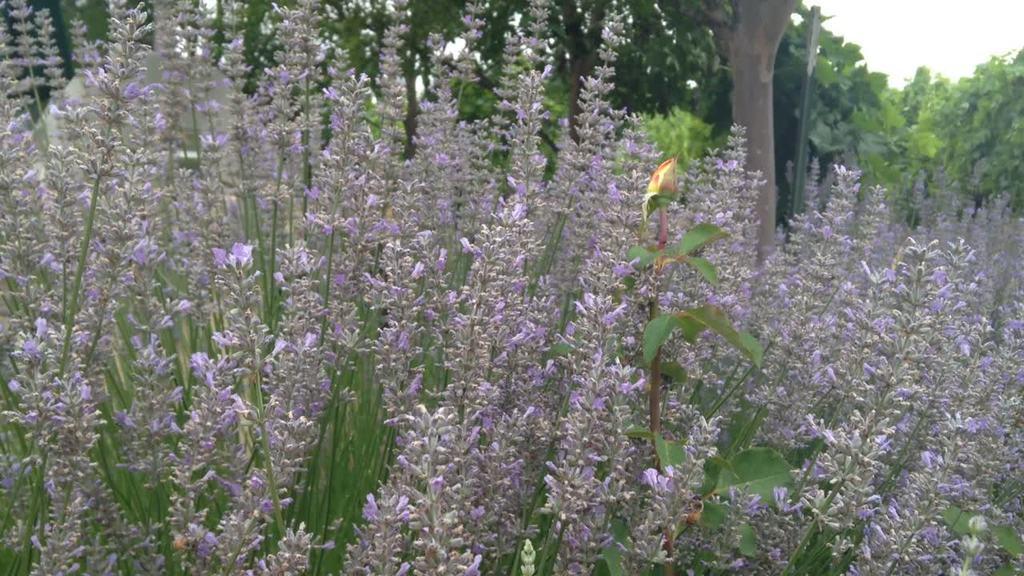Please provide a concise description of this image. In this image we can see flower plants and in the background we can see the trees. 